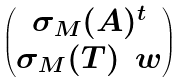<formula> <loc_0><loc_0><loc_500><loc_500>\begin{pmatrix} \sigma _ { M } ( A ) ^ { t } \\ \sigma _ { M } ( T ) \, \ w \end{pmatrix}</formula> 